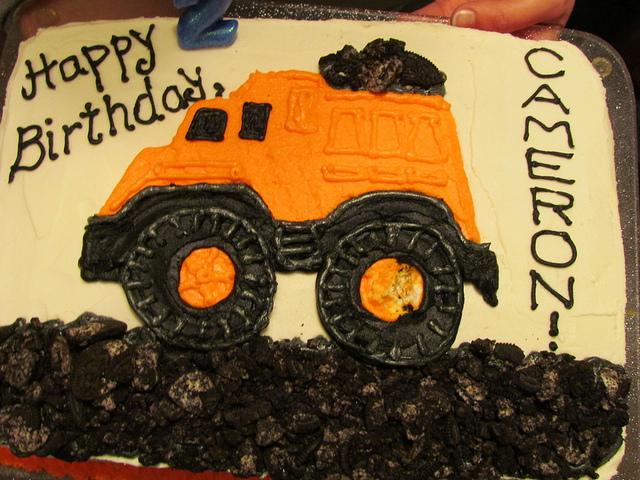What type of truck is that?
Short answer required. Dump truck. Is there icing on this cake?
Concise answer only. Yes. Whose birthday is this?
Answer briefly. Cameron. 